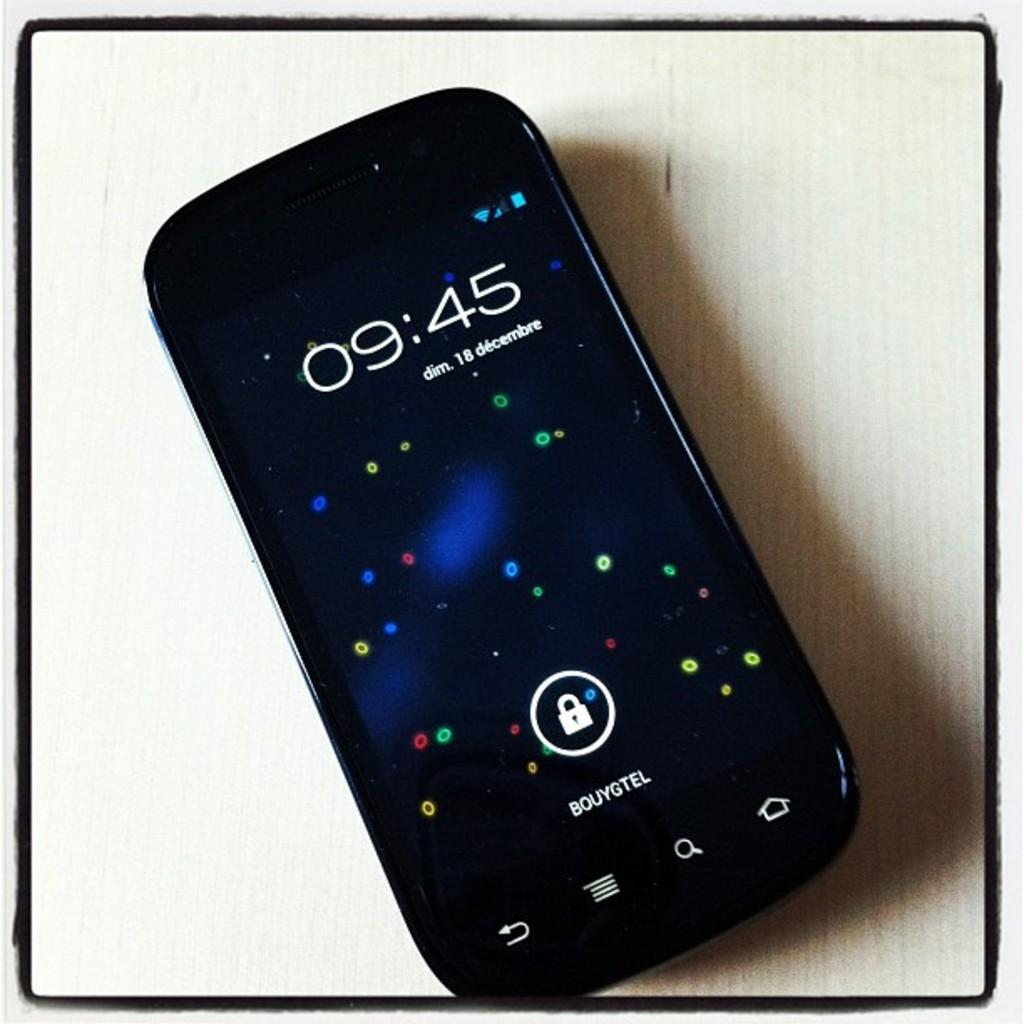<image>
Render a clear and concise summary of the photo. An electronic device  that says 9:45 on it. 